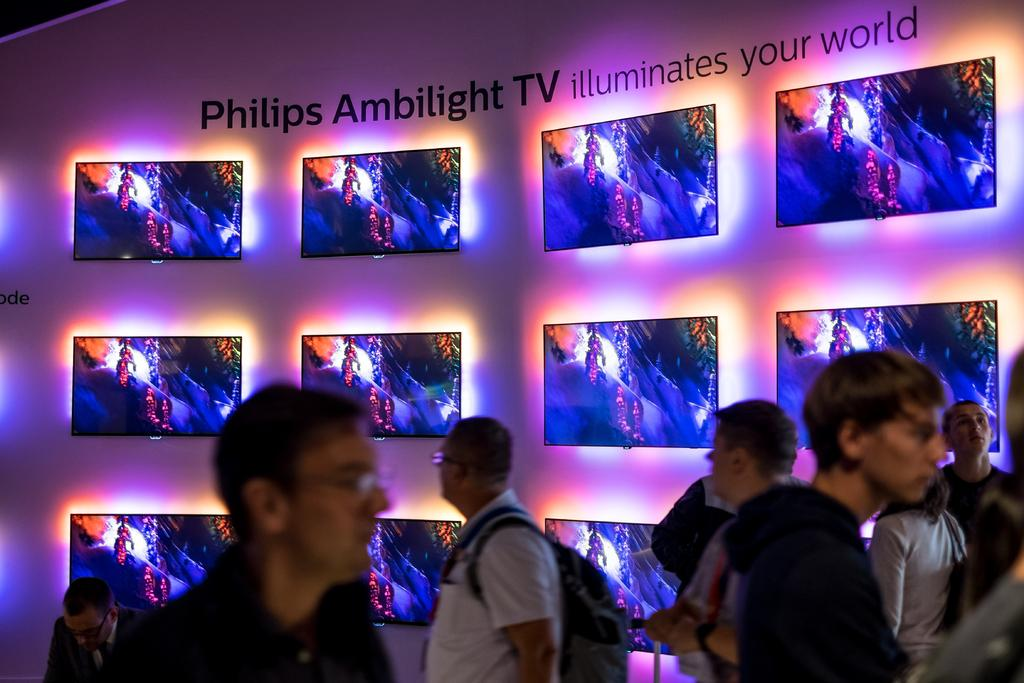Who or what can be seen in the image? There are people in the image. What is present on the wall in the background of the image? There are screens placed on the wall in the background of the image. Can you read any text in the image? Yes, there is text visible in the image. Can you see a river flowing in the image? There is no river present in the image. What type of ship can be seen sailing in the background of the image? There is no ship visible in the image. 